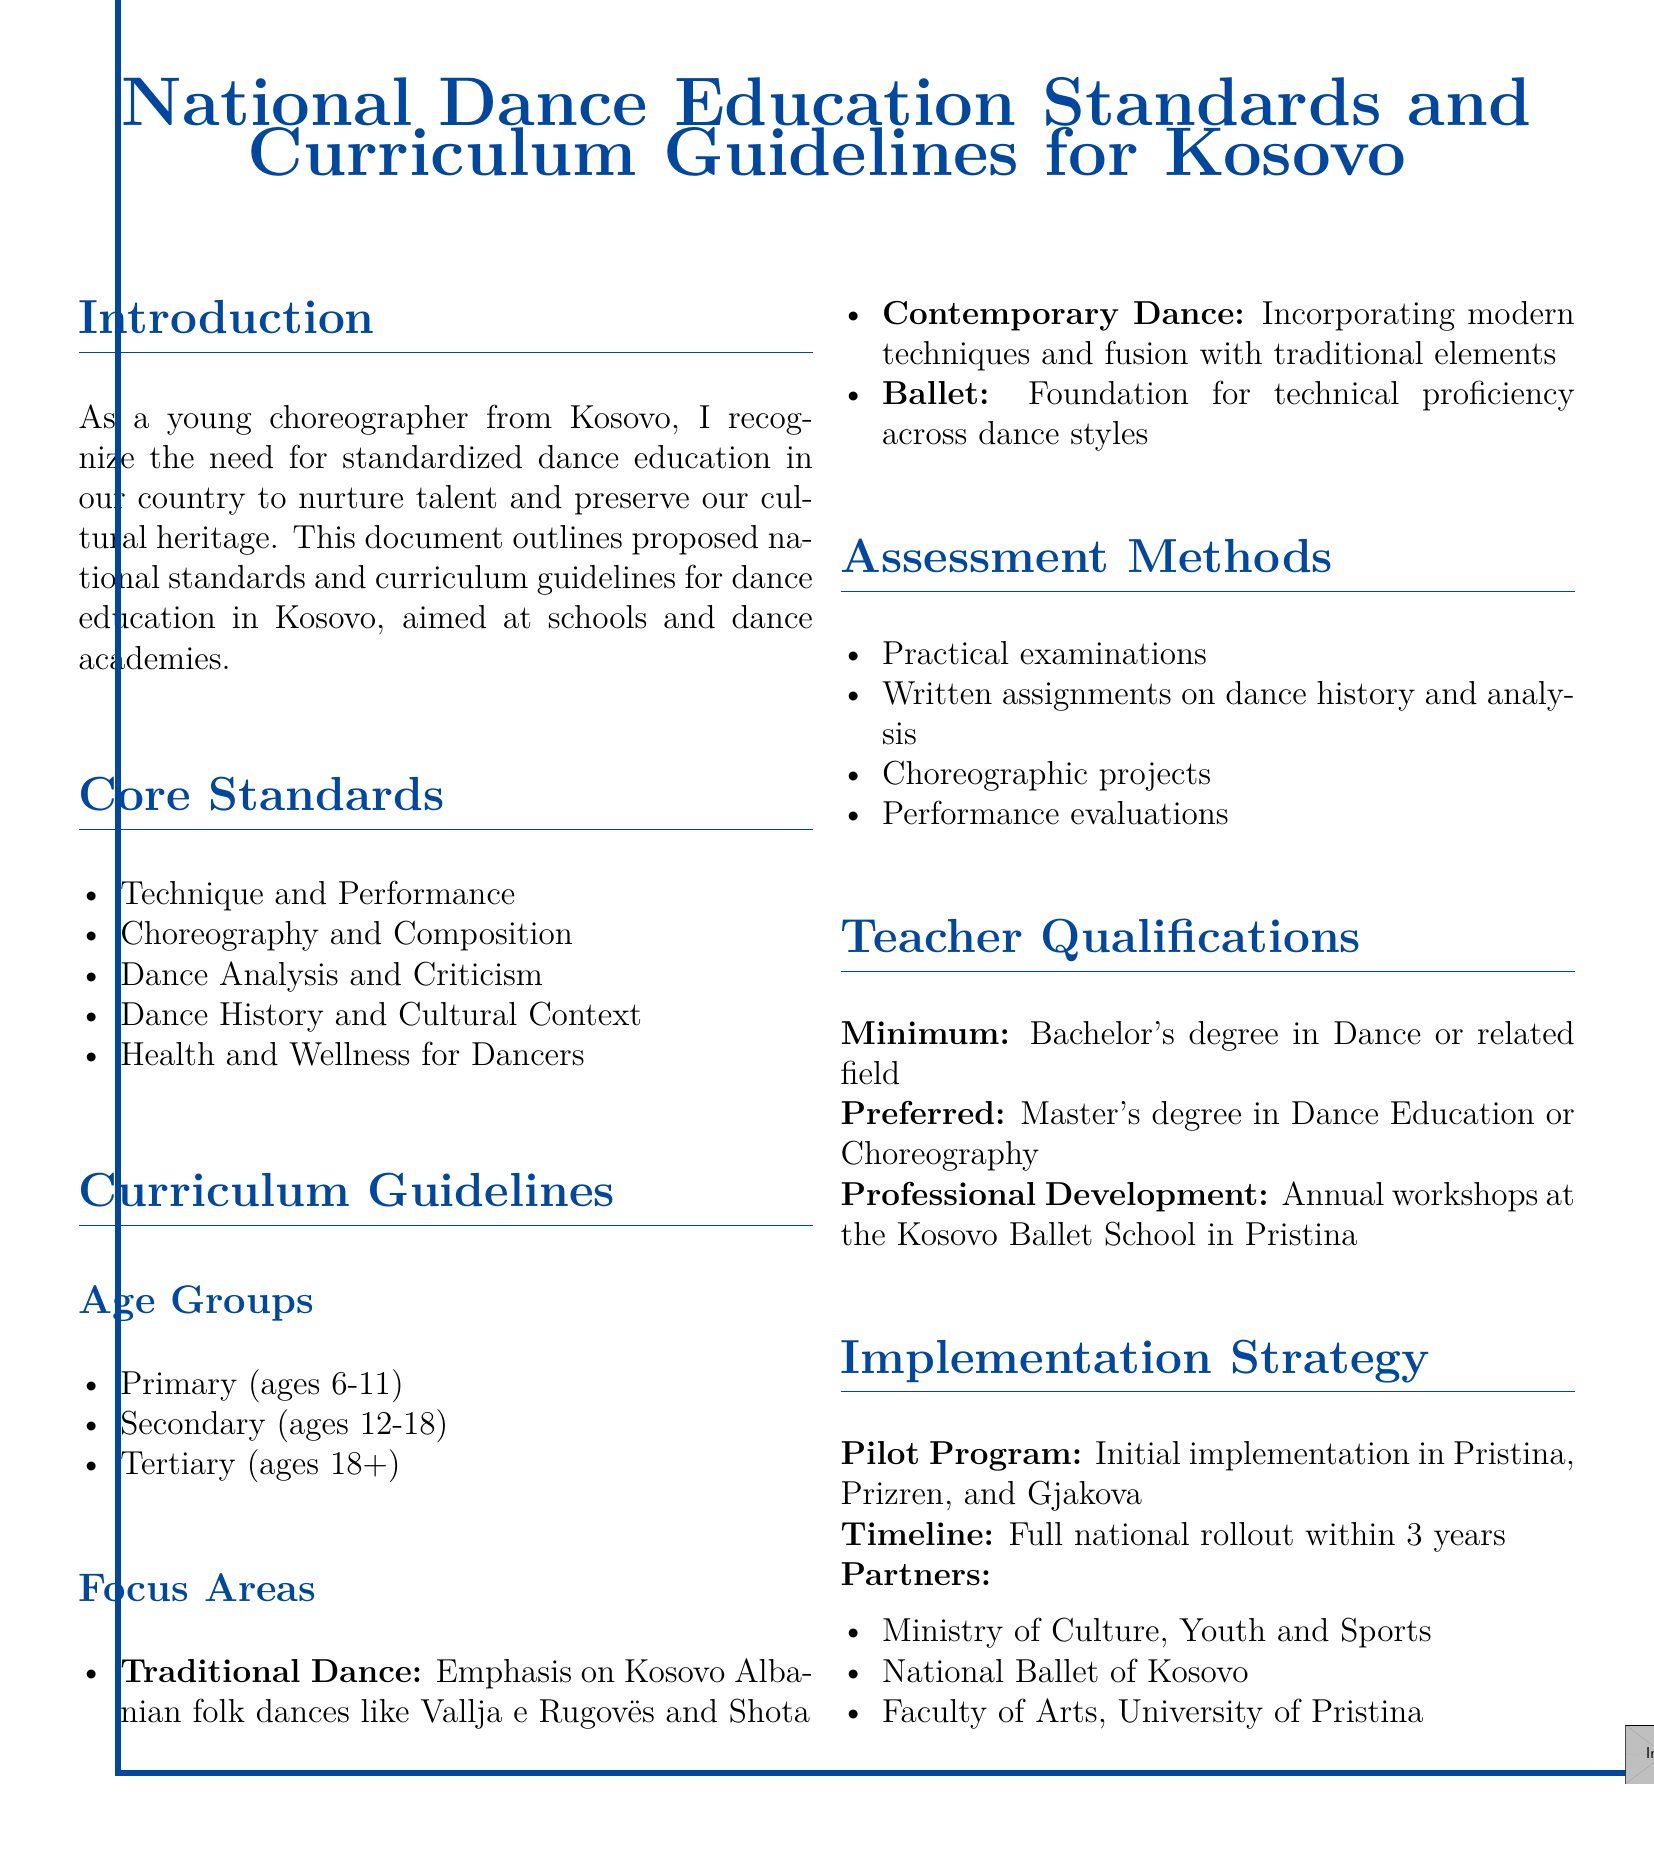What are the core standards outlined in the document? The core standards listed in the document include five areas that are essential for dance education.
Answer: Technique and Performance, Choreography and Composition, Dance Analysis and Criticism, Dance History and Cultural Context, Health and Wellness for Dancers What is the focus area for traditional dance? The document specifies a particular emphasis on a type of dance that is culturally significant to Kosovo.
Answer: Kosovo Albanian folk dances like Vallja e Rugovës and Shota How many age groups are mentioned in the curriculum guidelines? The document categorizes dance education into specific age groups.
Answer: Three What is the minimum qualification for teachers according to the document? The document states a specific educational background required for teachers in dance education.
Answer: Bachelor's degree in Dance or related field What is the proposed timeline for the full national rollout? The document indicates a specific time frame for implementing the dance education standards across the country.
Answer: Three years Which organization is listed as a partner for the implementation strategy? The document highlights specific partners that will be involved in the rollout of dance education standards.
Answer: Ministry of Culture, Youth and Sports What type of examinations are included in the assessment methods? The document describes a specific method of evaluating students’ performance in dance education.
Answer: Practical examinations What is the preferred qualification for teachers according to the document? The document provides information on an advanced educational credential that enhances a teacher's profile.
Answer: Master's degree in Dance Education or Choreography 